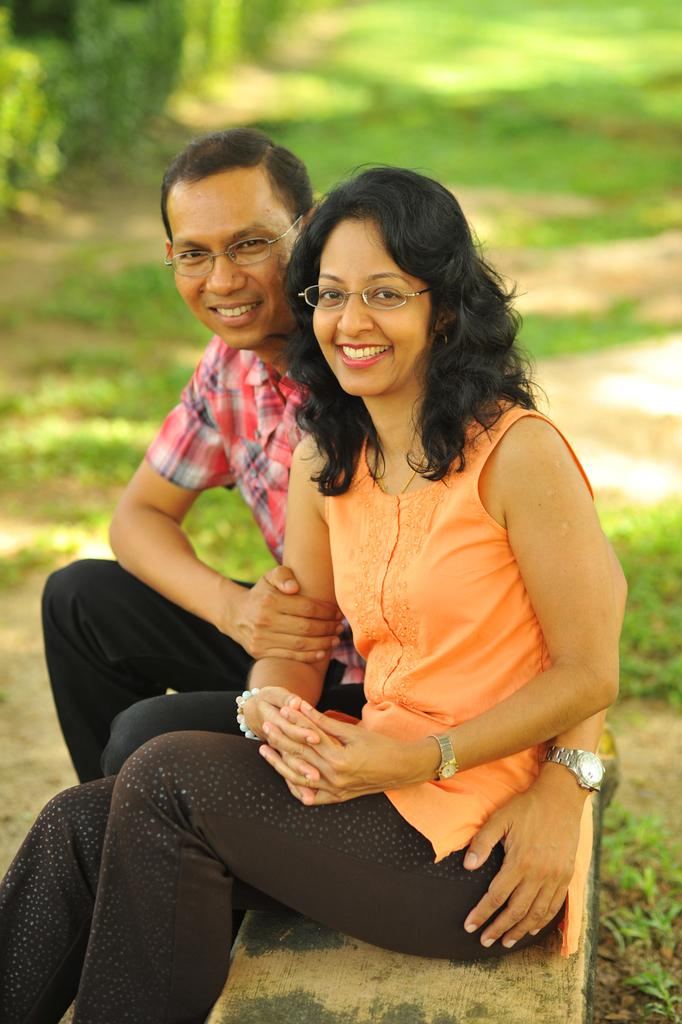Who is present in the image? There is a man and a woman in the image. What are the man and woman doing in the image? The man and woman are sitting on a bench. What is the emotional expression of the man and woman in the image? The man and woman are smiling. What type of vegetation can be seen behind the man and woman? There are plants behind them. What is the ground made of in the image? There is grass on the ground. What type of arm is visible in the image? There is no arm mentioned or visible in the image; it features a man and a woman sitting on a bench. What is the earth like in the image? The image does not show the earth as a planet or any specific details about the earth's surface or condition. 